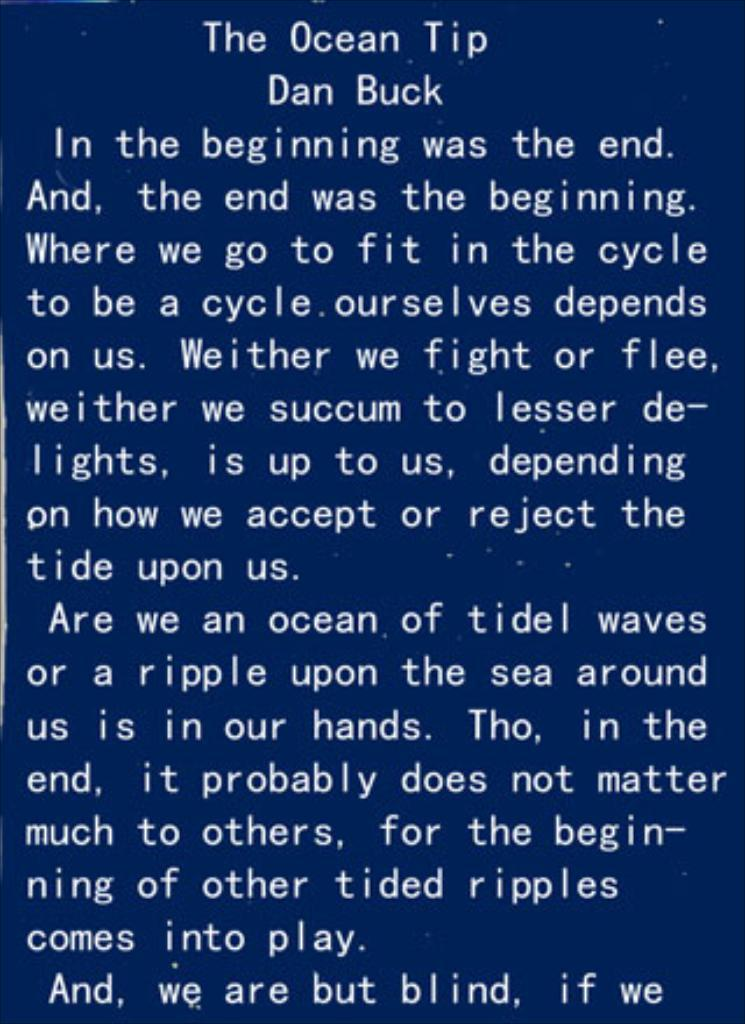<image>
Give a short and clear explanation of the subsequent image. White text with a blue background which is titled,"The Ocean Tip" by Dan Buck. 